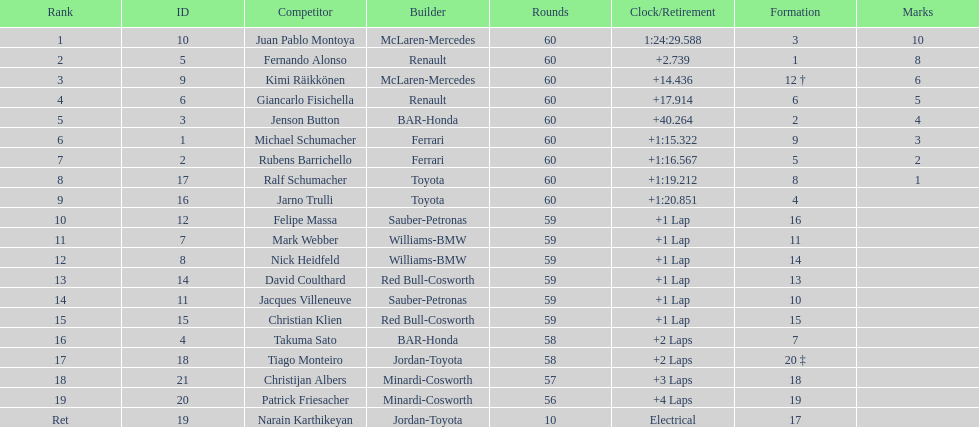After 8th position, how many points does a driver receive? 0. 